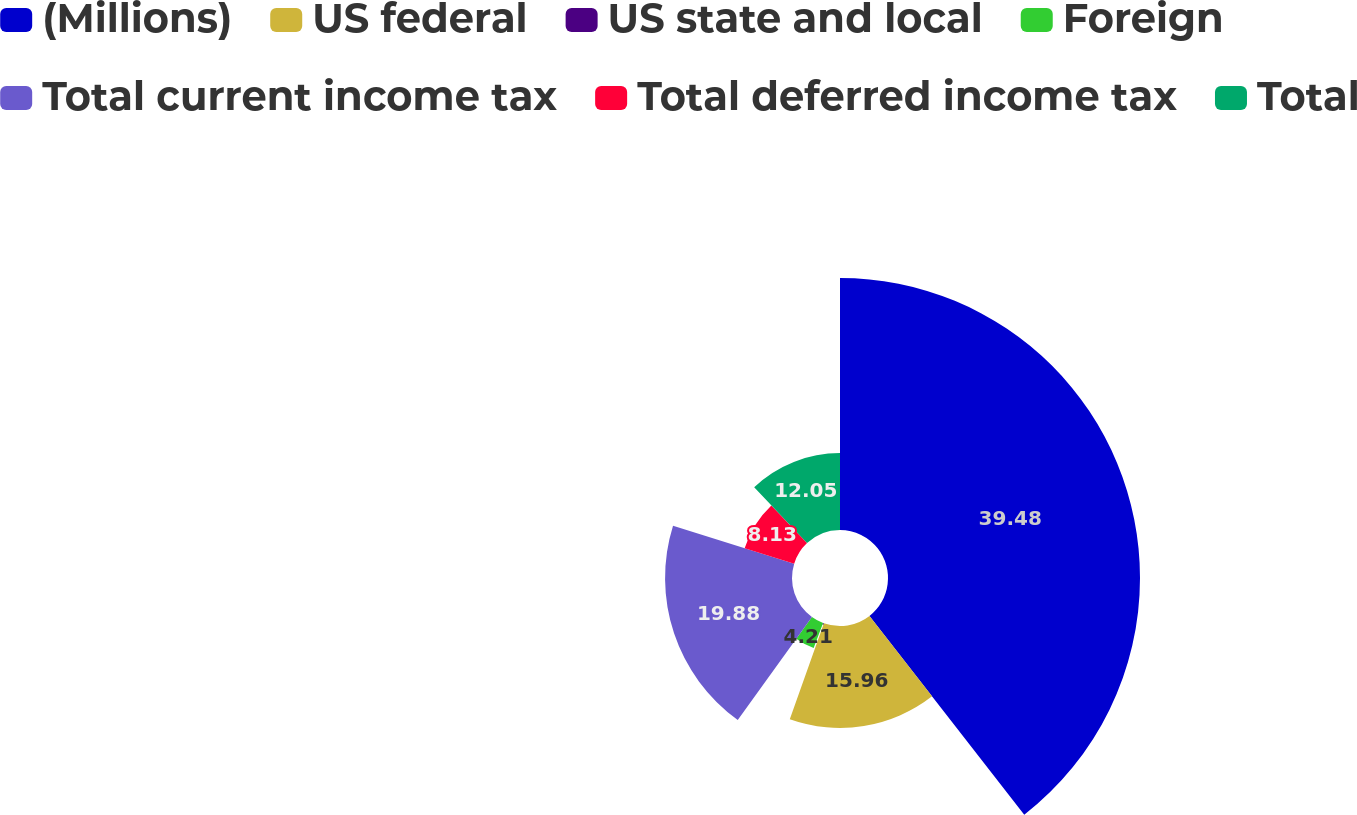Convert chart to OTSL. <chart><loc_0><loc_0><loc_500><loc_500><pie_chart><fcel>(Millions)<fcel>US federal<fcel>US state and local<fcel>Foreign<fcel>Total current income tax<fcel>Total deferred income tax<fcel>Total<nl><fcel>39.47%<fcel>15.96%<fcel>0.29%<fcel>4.21%<fcel>19.88%<fcel>8.13%<fcel>12.05%<nl></chart> 